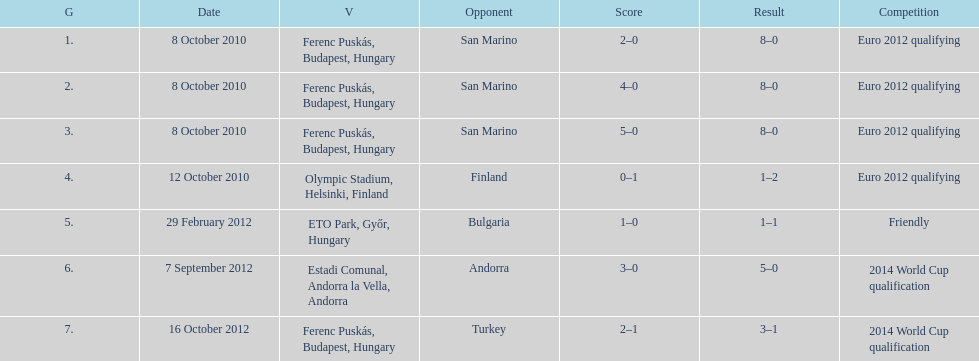How many goals were scored at the euro 2012 qualifying competition? 12. 